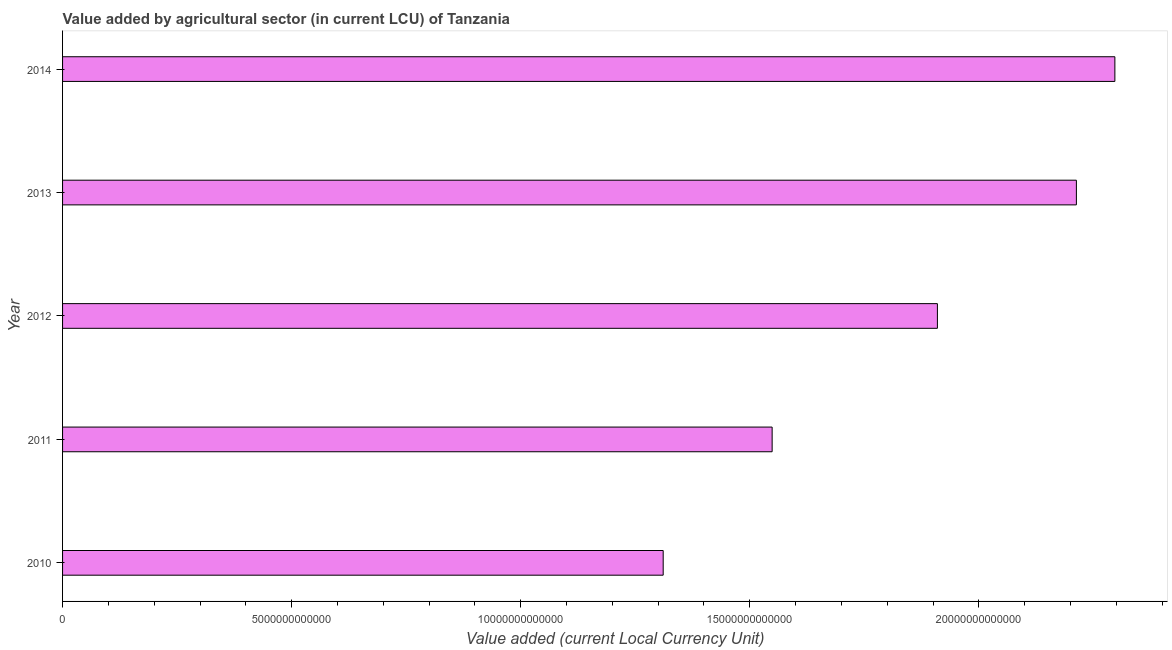Does the graph contain any zero values?
Provide a short and direct response. No. Does the graph contain grids?
Make the answer very short. No. What is the title of the graph?
Keep it short and to the point. Value added by agricultural sector (in current LCU) of Tanzania. What is the label or title of the X-axis?
Your answer should be very brief. Value added (current Local Currency Unit). What is the label or title of the Y-axis?
Provide a succinct answer. Year. What is the value added by agriculture sector in 2010?
Make the answer very short. 1.31e+13. Across all years, what is the maximum value added by agriculture sector?
Keep it short and to the point. 2.30e+13. Across all years, what is the minimum value added by agriculture sector?
Keep it short and to the point. 1.31e+13. In which year was the value added by agriculture sector maximum?
Keep it short and to the point. 2014. What is the sum of the value added by agriculture sector?
Ensure brevity in your answer.  9.28e+13. What is the difference between the value added by agriculture sector in 2011 and 2014?
Keep it short and to the point. -7.48e+12. What is the average value added by agriculture sector per year?
Make the answer very short. 1.86e+13. What is the median value added by agriculture sector?
Your answer should be compact. 1.91e+13. In how many years, is the value added by agriculture sector greater than 7000000000000 LCU?
Provide a short and direct response. 5. What is the ratio of the value added by agriculture sector in 2010 to that in 2013?
Make the answer very short. 0.59. Is the difference between the value added by agriculture sector in 2012 and 2013 greater than the difference between any two years?
Provide a short and direct response. No. What is the difference between the highest and the second highest value added by agriculture sector?
Offer a terse response. 8.40e+11. What is the difference between the highest and the lowest value added by agriculture sector?
Your answer should be very brief. 9.86e+12. How many bars are there?
Your answer should be compact. 5. Are all the bars in the graph horizontal?
Make the answer very short. Yes. What is the difference between two consecutive major ticks on the X-axis?
Keep it short and to the point. 5.00e+12. What is the Value added (current Local Currency Unit) in 2010?
Your answer should be compact. 1.31e+13. What is the Value added (current Local Currency Unit) in 2011?
Your answer should be compact. 1.55e+13. What is the Value added (current Local Currency Unit) of 2012?
Give a very brief answer. 1.91e+13. What is the Value added (current Local Currency Unit) in 2013?
Offer a terse response. 2.21e+13. What is the Value added (current Local Currency Unit) of 2014?
Make the answer very short. 2.30e+13. What is the difference between the Value added (current Local Currency Unit) in 2010 and 2011?
Keep it short and to the point. -2.38e+12. What is the difference between the Value added (current Local Currency Unit) in 2010 and 2012?
Your answer should be compact. -5.99e+12. What is the difference between the Value added (current Local Currency Unit) in 2010 and 2013?
Offer a very short reply. -9.02e+12. What is the difference between the Value added (current Local Currency Unit) in 2010 and 2014?
Make the answer very short. -9.86e+12. What is the difference between the Value added (current Local Currency Unit) in 2011 and 2012?
Your answer should be compact. -3.61e+12. What is the difference between the Value added (current Local Currency Unit) in 2011 and 2013?
Keep it short and to the point. -6.64e+12. What is the difference between the Value added (current Local Currency Unit) in 2011 and 2014?
Your answer should be very brief. -7.48e+12. What is the difference between the Value added (current Local Currency Unit) in 2012 and 2013?
Make the answer very short. -3.03e+12. What is the difference between the Value added (current Local Currency Unit) in 2012 and 2014?
Offer a terse response. -3.87e+12. What is the difference between the Value added (current Local Currency Unit) in 2013 and 2014?
Make the answer very short. -8.40e+11. What is the ratio of the Value added (current Local Currency Unit) in 2010 to that in 2011?
Provide a short and direct response. 0.85. What is the ratio of the Value added (current Local Currency Unit) in 2010 to that in 2012?
Provide a succinct answer. 0.69. What is the ratio of the Value added (current Local Currency Unit) in 2010 to that in 2013?
Give a very brief answer. 0.59. What is the ratio of the Value added (current Local Currency Unit) in 2010 to that in 2014?
Your answer should be compact. 0.57. What is the ratio of the Value added (current Local Currency Unit) in 2011 to that in 2012?
Your response must be concise. 0.81. What is the ratio of the Value added (current Local Currency Unit) in 2011 to that in 2014?
Offer a terse response. 0.67. What is the ratio of the Value added (current Local Currency Unit) in 2012 to that in 2013?
Keep it short and to the point. 0.86. What is the ratio of the Value added (current Local Currency Unit) in 2012 to that in 2014?
Give a very brief answer. 0.83. 